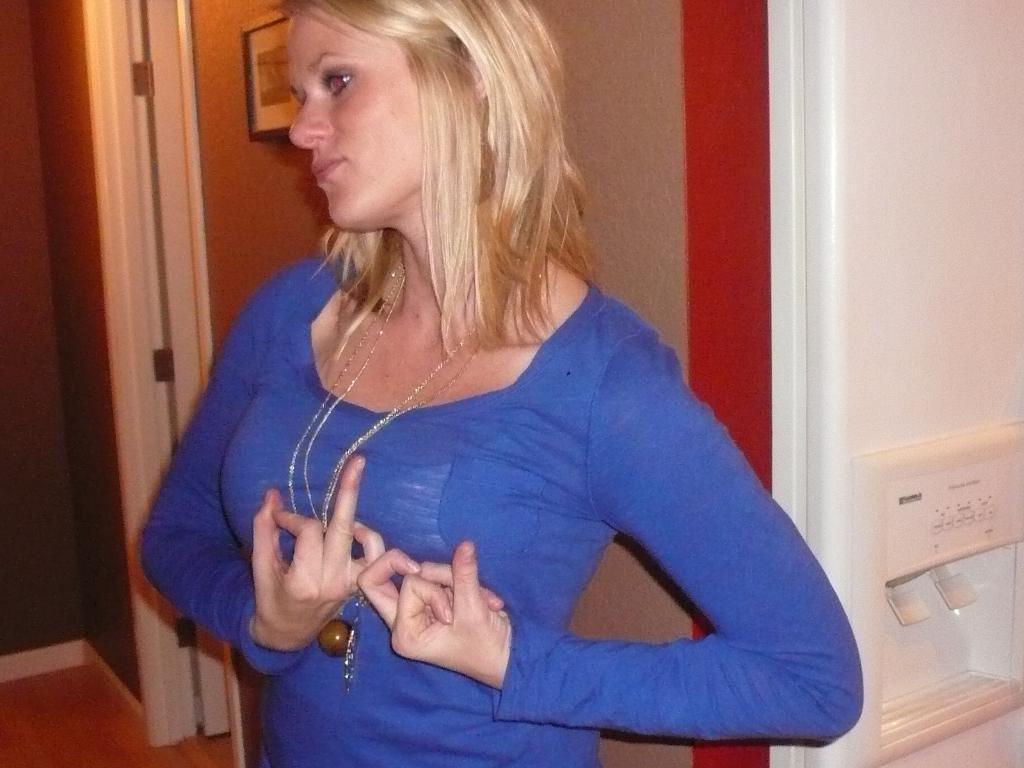Describe this image in one or two sentences. In the picture I can see a woman is standing and wearing blue color clothes. In the background I can see walls and some other things. 